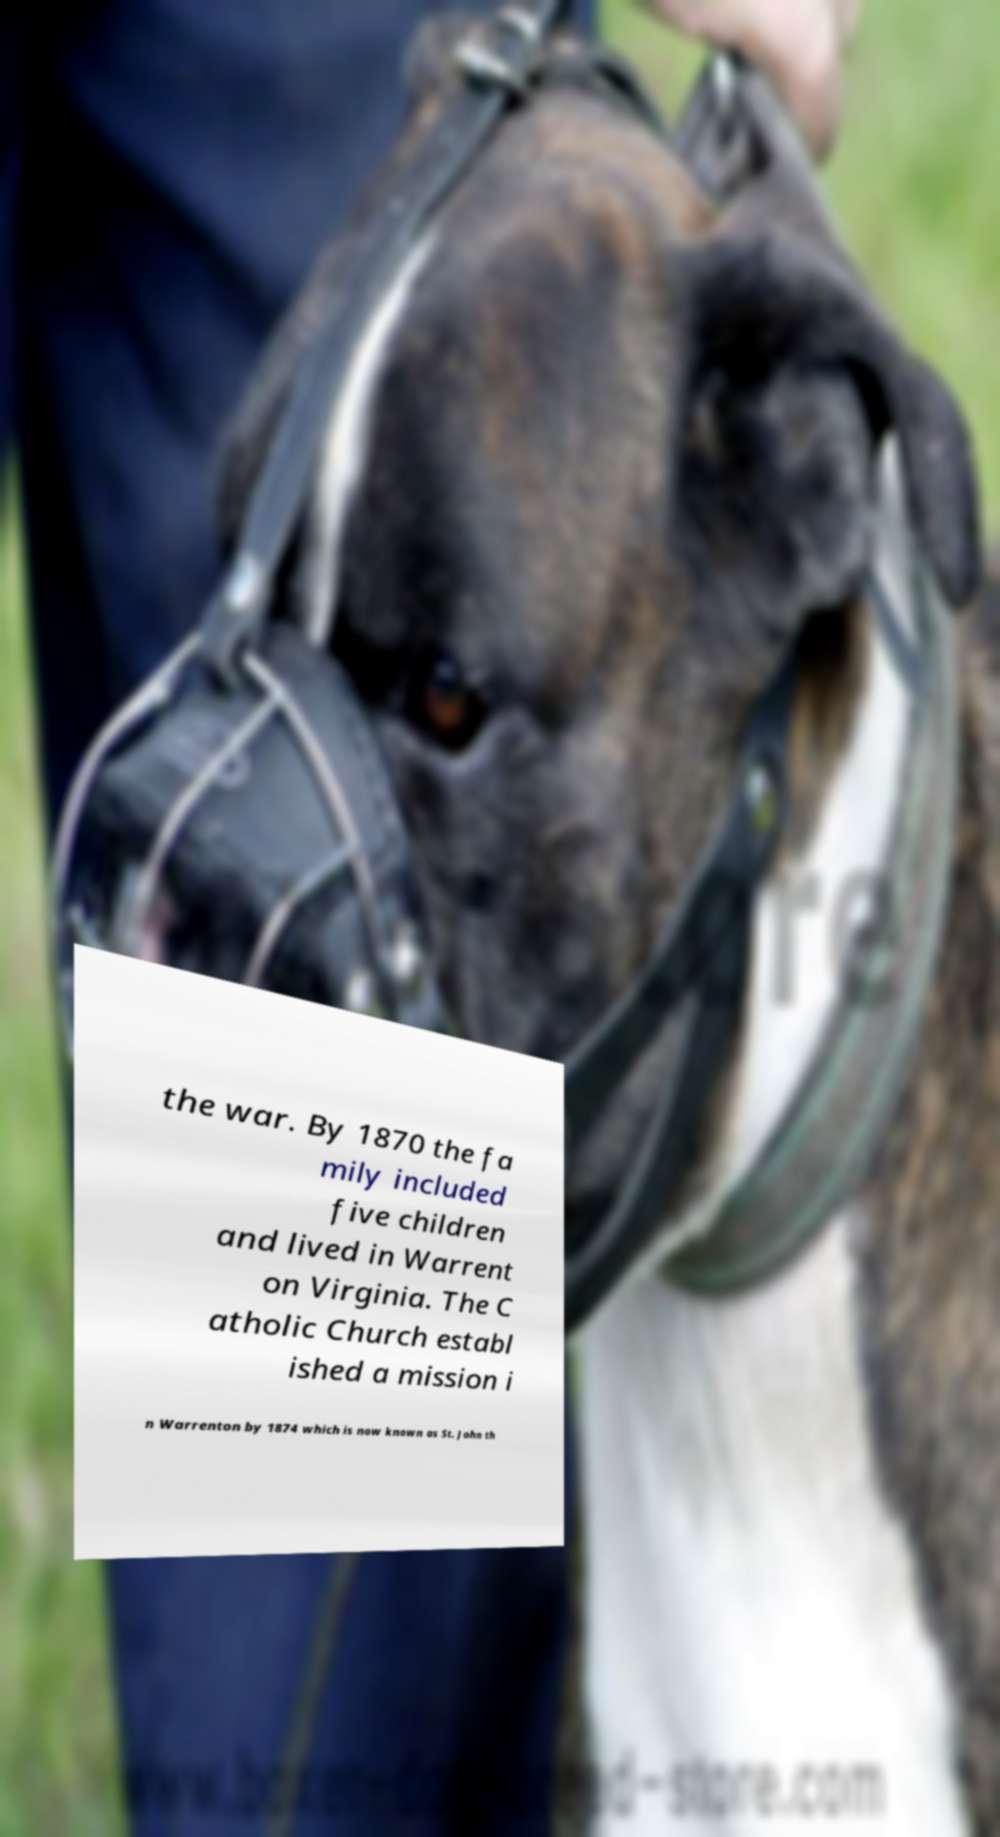There's text embedded in this image that I need extracted. Can you transcribe it verbatim? the war. By 1870 the fa mily included five children and lived in Warrent on Virginia. The C atholic Church establ ished a mission i n Warrenton by 1874 which is now known as St. John th 